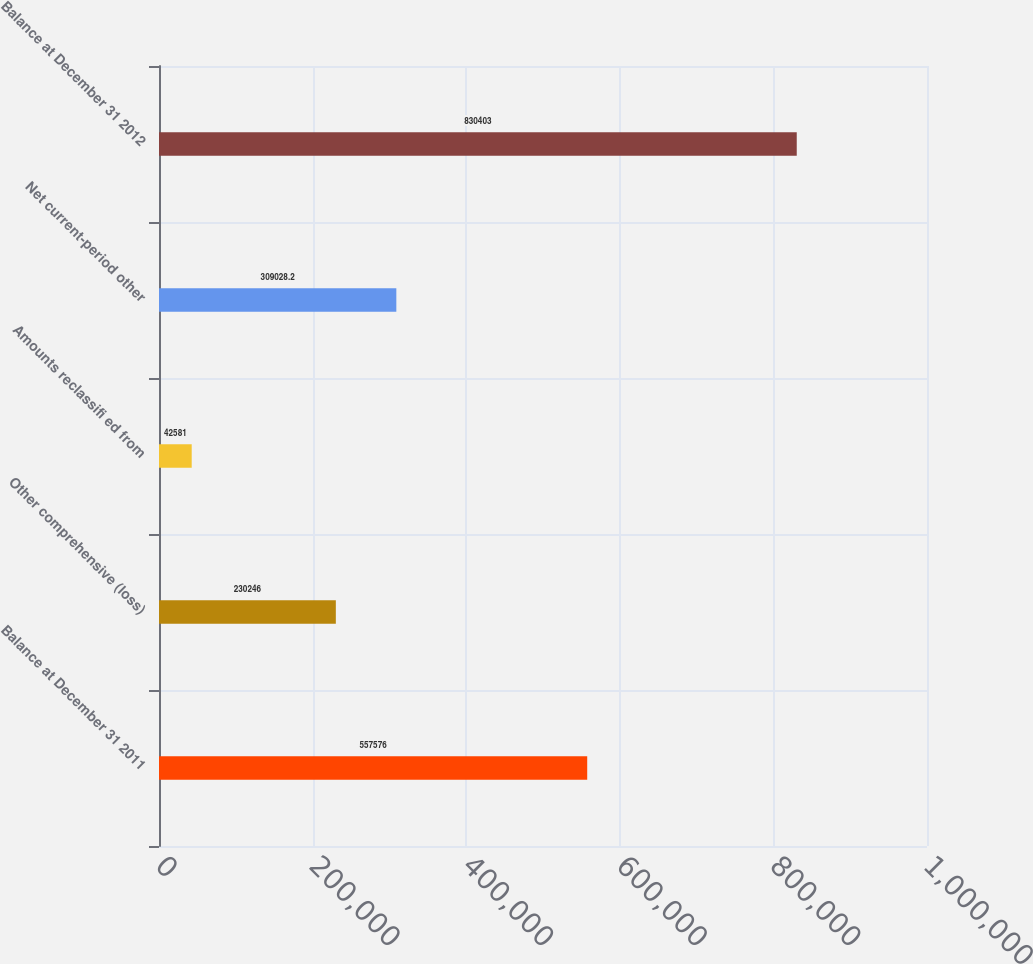Convert chart. <chart><loc_0><loc_0><loc_500><loc_500><bar_chart><fcel>Balance at December 31 2011<fcel>Other comprehensive (loss)<fcel>Amounts reclassifi ed from<fcel>Net current-period other<fcel>Balance at December 31 2012<nl><fcel>557576<fcel>230246<fcel>42581<fcel>309028<fcel>830403<nl></chart> 